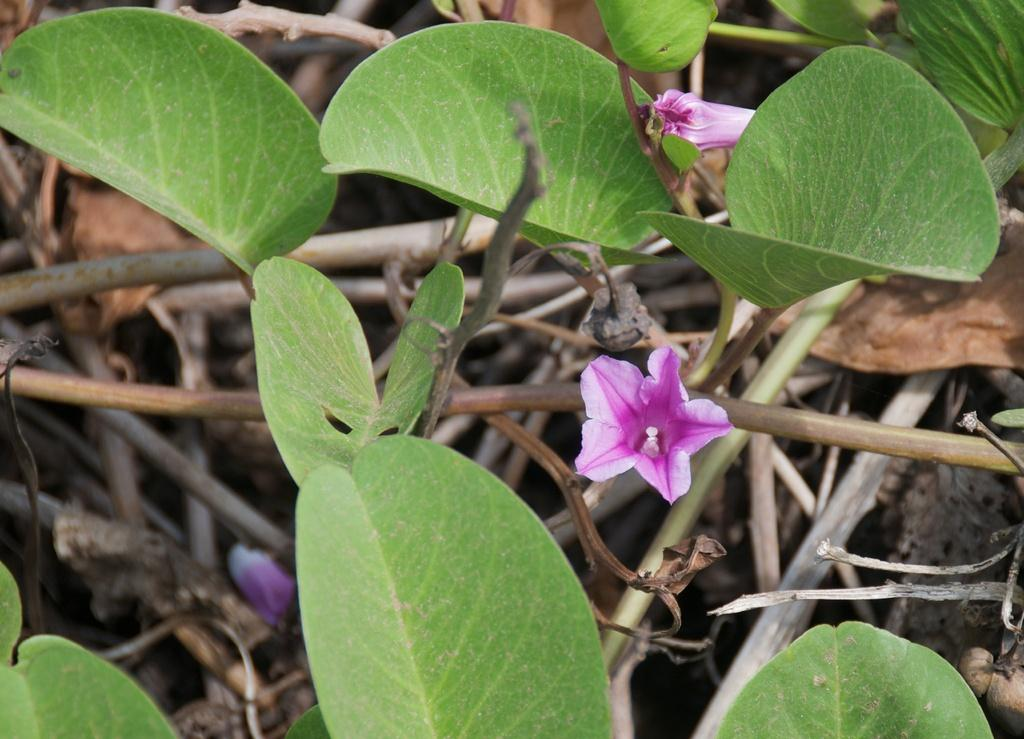What type of flowers are present in the image? There are pink color flowers in the image. What other parts of the plants can be seen in the image? There are leaves and stems in the image. What type of learning agreement is required for the flowers in the image? There is no mention of any learning agreement in the image; it simply features flowers, leaves, and stems. 